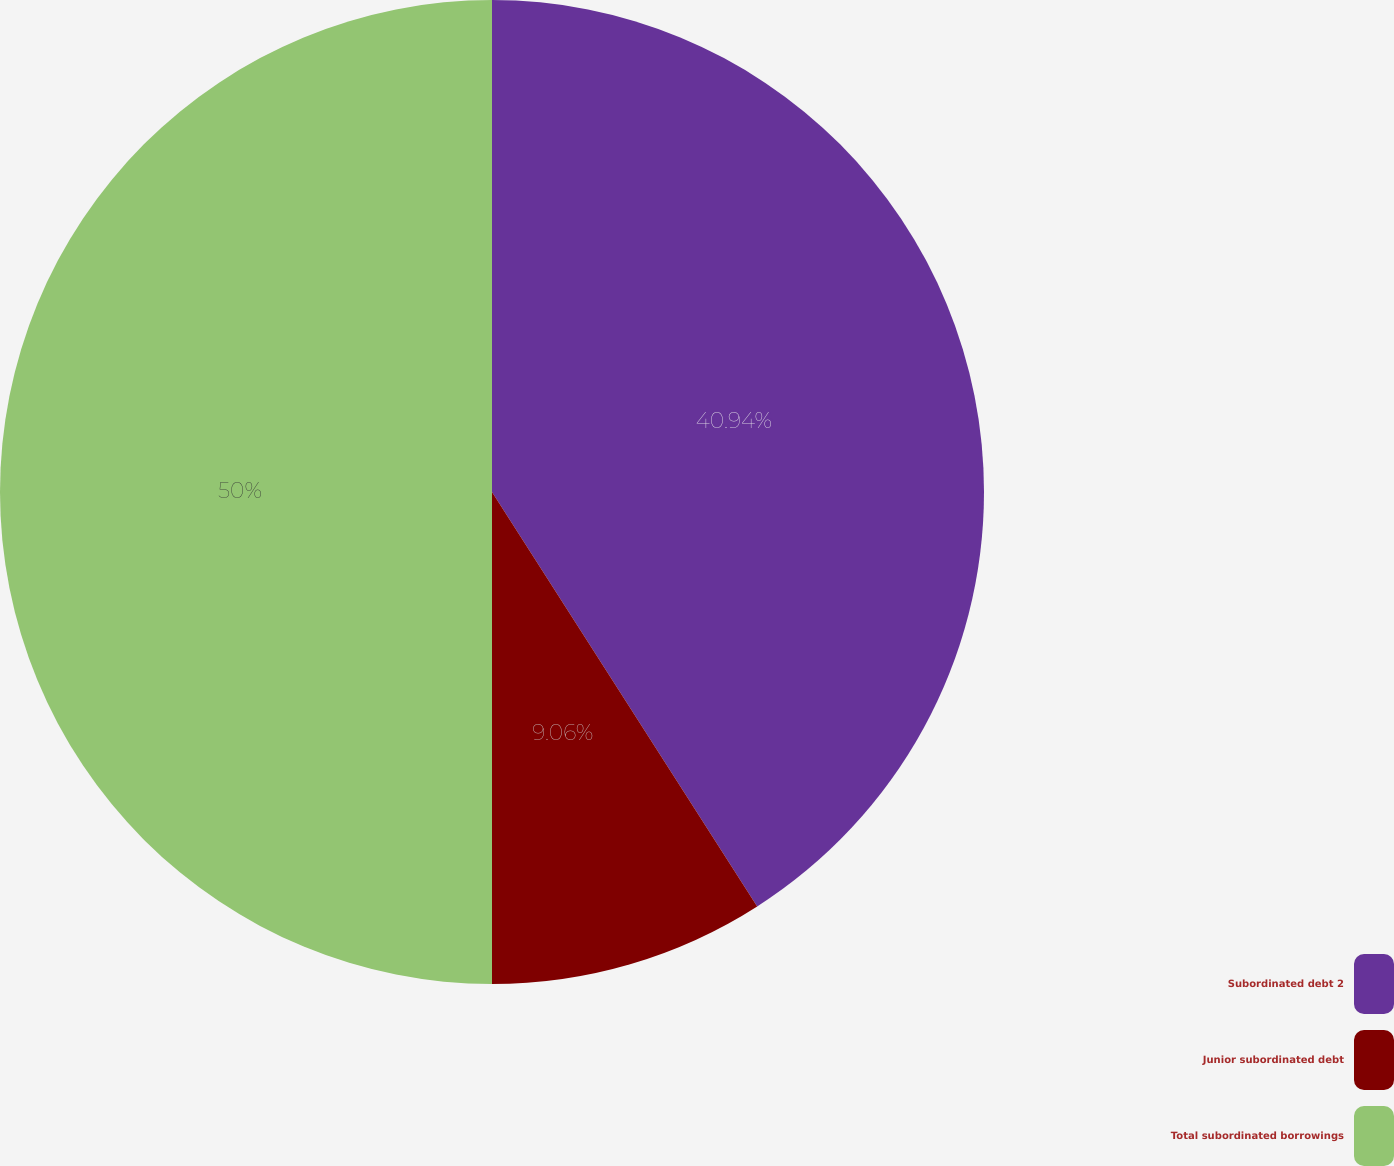Convert chart. <chart><loc_0><loc_0><loc_500><loc_500><pie_chart><fcel>Subordinated debt 2<fcel>Junior subordinated debt<fcel>Total subordinated borrowings<nl><fcel>40.94%<fcel>9.06%<fcel>50.0%<nl></chart> 